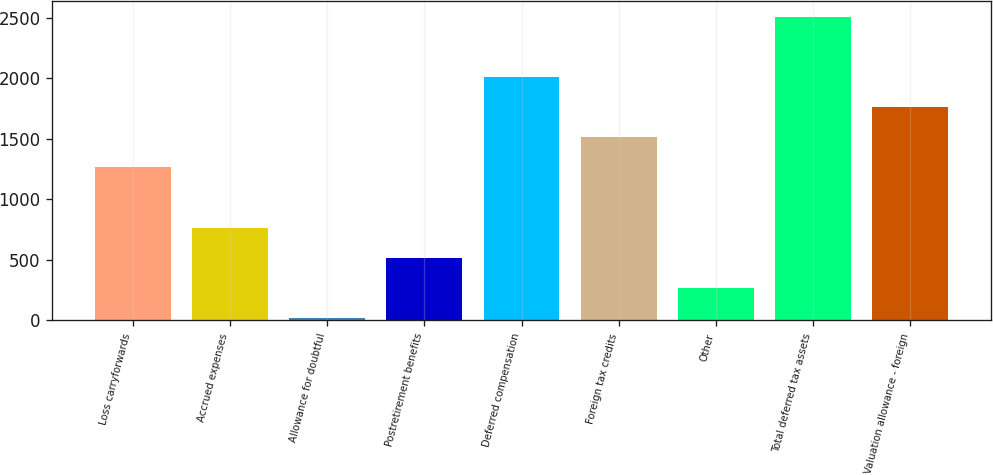Convert chart to OTSL. <chart><loc_0><loc_0><loc_500><loc_500><bar_chart><fcel>Loss carryforwards<fcel>Accrued expenses<fcel>Allowance for doubtful<fcel>Postretirement benefits<fcel>Deferred compensation<fcel>Foreign tax credits<fcel>Other<fcel>Total deferred tax assets<fcel>Valuation allowance - foreign<nl><fcel>1265<fcel>767<fcel>20<fcel>518<fcel>2012<fcel>1514<fcel>269<fcel>2510<fcel>1763<nl></chart> 